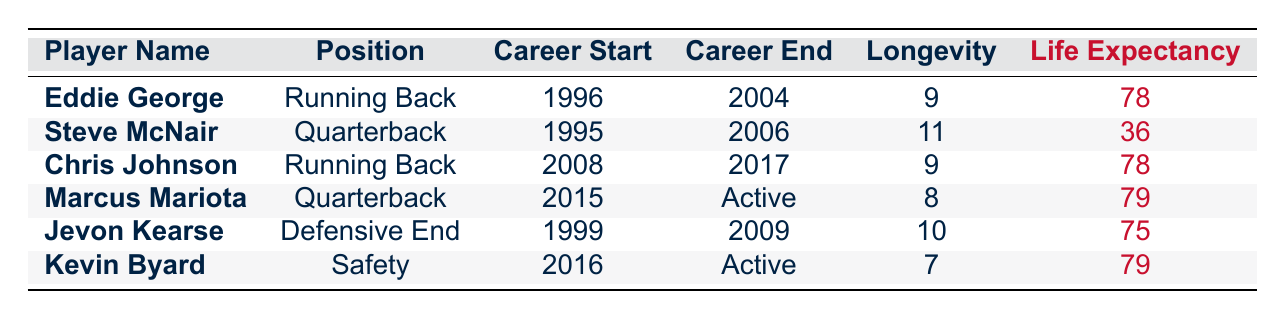What is the career longevity of Eddie George? According to the table, the career longevity of Eddie George is listed directly in the corresponding row, which shows 9 years.
Answer: 9 Which player has the highest life expectancy? By examining the Life Expectancy column, we see both Chris Johnson and Marcus Mariota have values of 79, which is the highest amongst all players listed.
Answer: 79 Is Marcus Mariota still an active player? The table indicates that Marcus Mariota's career end year is marked as "Active," confirming that he is still playing.
Answer: Yes What is the average career longevity of the players listed? To find the average, add up the career longevity values: 9 (Eddie George) + 11 (Steve McNair) + 9 (Chris Johnson) + 8 (Marcus Mariota) + 10 (Jevon Kearse) + 7 (Kevin Byard) = 54. There are 6 players, so 54/6 = 9.
Answer: 9 Did any of the players have a life expectancy below 40? Checking the Life Expectancy column, Steve McNair is the only player who has a life expectancy of 36, which is below 40.
Answer: Yes What is the combined career longevity of all the active players? The active players listed are Marcus Mariota and Kevin Byard. Their career longevity is 8 and 7 years, respectively. Adding them together gives 8 + 7 = 15 years.
Answer: 15 How many players mentioned in the table had careers that spanned over 10 years? By reviewing the Career Longevity column, we see that only Steve McNair (11 years) and Jevon Kearse (10 years) had careers spanning over 10 years. Therefore, there are 2 players.
Answer: 2 What was the career end year for Chris Johnson? Looking at the Career End Year column for Chris Johnson, we see it is listed as 2017.
Answer: 2017 Are there more players with a life expectancy of 78 or 79? From the table, Chris Johnson and Eddie George both have a life expectancy of 78 while both Marcus Mariota and Kevin Byard have a life expectancy of 79. Therefore, there are 2 players with 78 and 2 players with 79, resulting in a tie.
Answer: Tie 